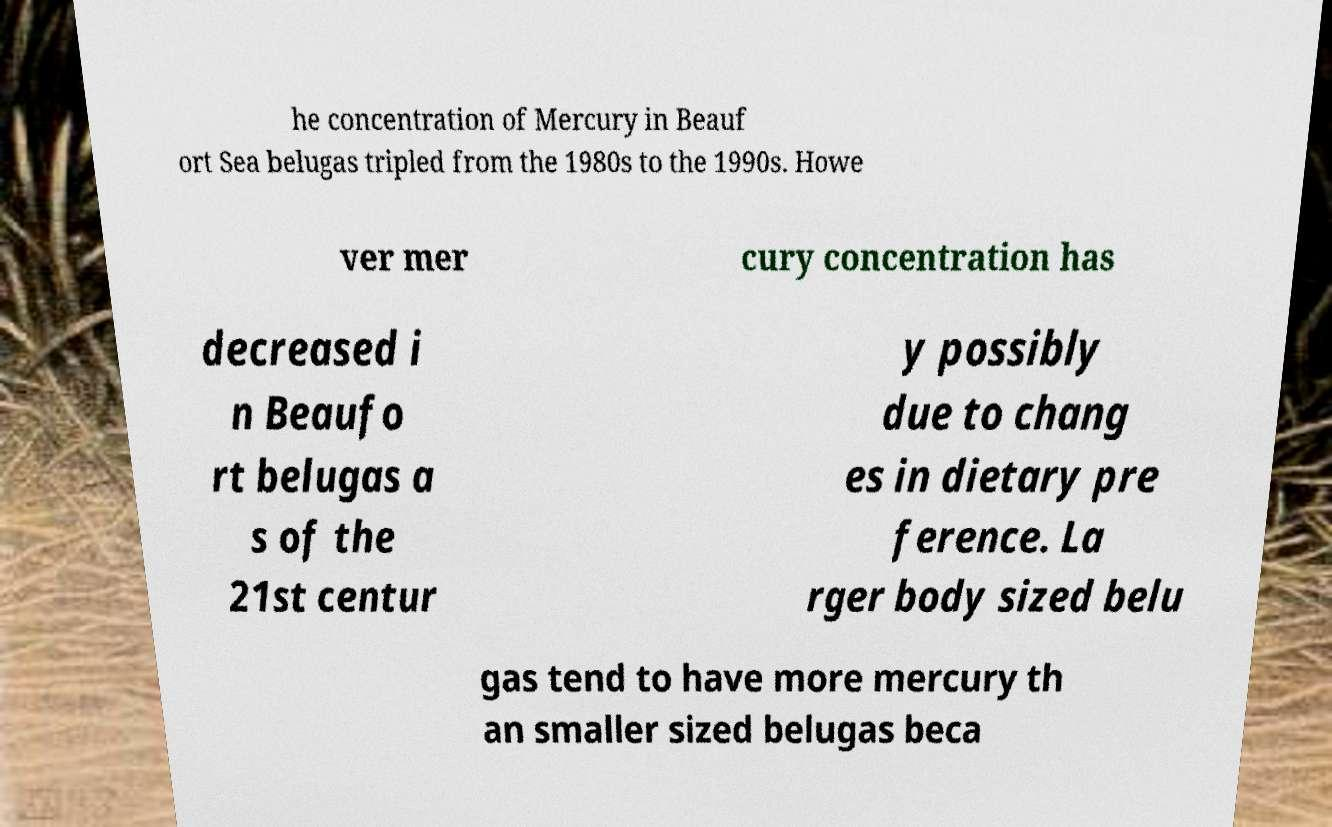For documentation purposes, I need the text within this image transcribed. Could you provide that? he concentration of Mercury in Beauf ort Sea belugas tripled from the 1980s to the 1990s. Howe ver mer cury concentration has decreased i n Beaufo rt belugas a s of the 21st centur y possibly due to chang es in dietary pre ference. La rger body sized belu gas tend to have more mercury th an smaller sized belugas beca 